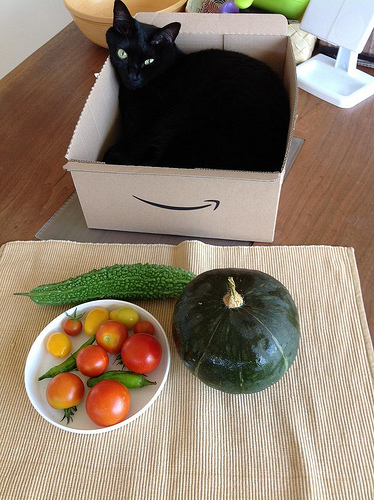<image>
Is there a smile on the box? Yes. Looking at the image, I can see the smile is positioned on top of the box, with the box providing support. Is there a pepper next to the tomato? Yes. The pepper is positioned adjacent to the tomato, located nearby in the same general area. Is there a cat above the box? No. The cat is not positioned above the box. The vertical arrangement shows a different relationship. 